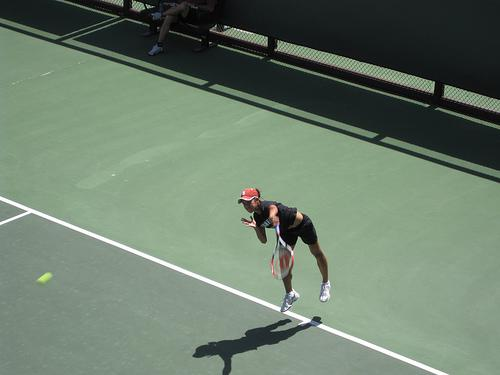Question: why does this ball look blurry?
Choices:
A. Broken camera.
B. The ball was in motion when the picture taken.
C. Ball is too bright.
D. It's too heavy.
Answer with the letter. Answer: B Question: what is the color of this tennis court?
Choices:
A. Green.
B. Red.
C. Orange.
D. Purple.
Answer with the letter. Answer: A Question: what game is this girl playing?
Choices:
A. Chess.
B. Monopoly.
C. Hockey.
D. Tennis.
Answer with the letter. Answer: D Question: who hit the tennis ball?
Choices:
A. Male player.
B. The female player.
C. The ref.
D. A fan.
Answer with the letter. Answer: B Question: what is this player wearing on the head?
Choices:
A. Hat.
B. Sweat band.
C. Helmet.
D. Bandana.
Answer with the letter. Answer: A Question: where is this picture taken?
Choices:
A. Zoo.
B. Tennis Court.
C. Park.
D. Hockey rink.
Answer with the letter. Answer: B Question: when was this picture taken?
Choices:
A. Afternoon.
B. Night.
C. Morning.
D. Christmas.
Answer with the letter. Answer: A 